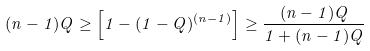<formula> <loc_0><loc_0><loc_500><loc_500>( n - 1 ) Q \geq \left [ 1 - ( 1 - Q ) ^ { ( n - 1 ) } \right ] \geq \frac { ( n - 1 ) Q } { 1 + ( n - 1 ) Q }</formula> 